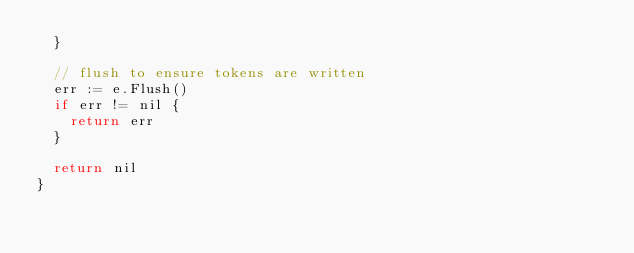<code> <loc_0><loc_0><loc_500><loc_500><_Go_>	}

	// flush to ensure tokens are written
	err := e.Flush()
	if err != nil {
		return err
	}

	return nil
}
</code> 